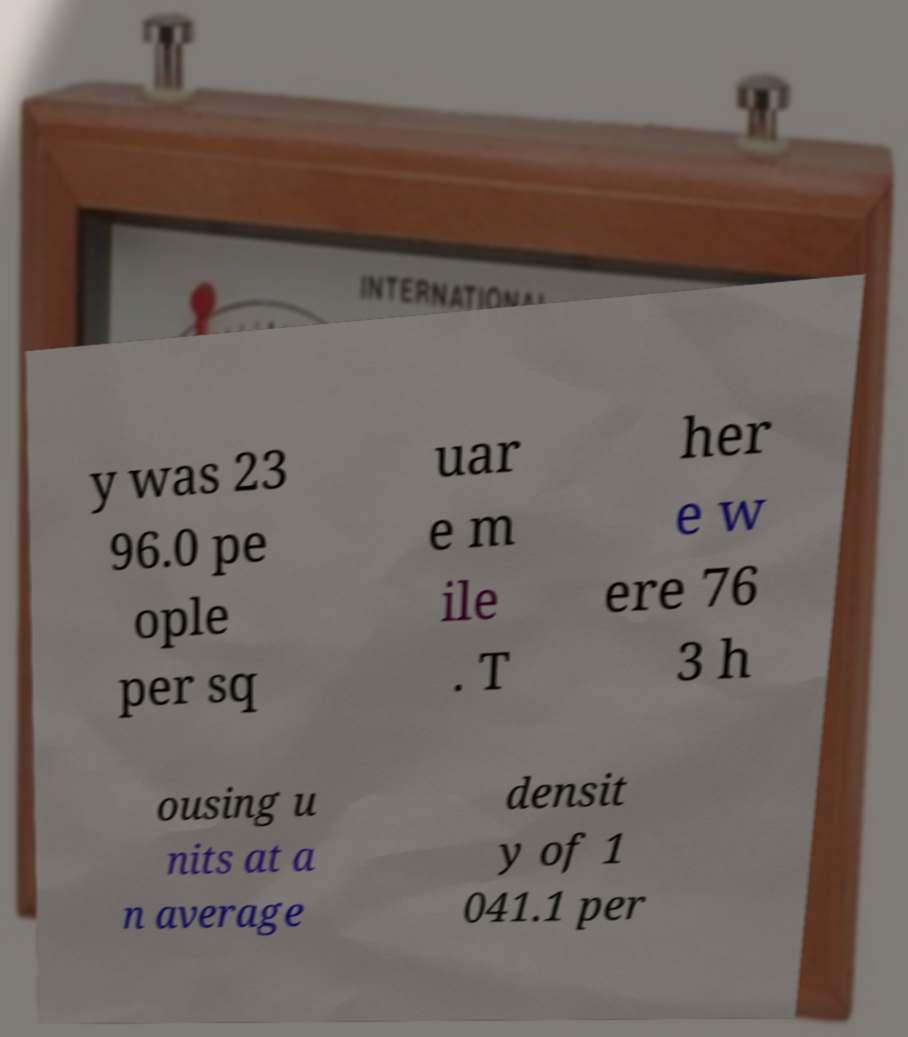Could you extract and type out the text from this image? y was 23 96.0 pe ople per sq uar e m ile . T her e w ere 76 3 h ousing u nits at a n average densit y of 1 041.1 per 